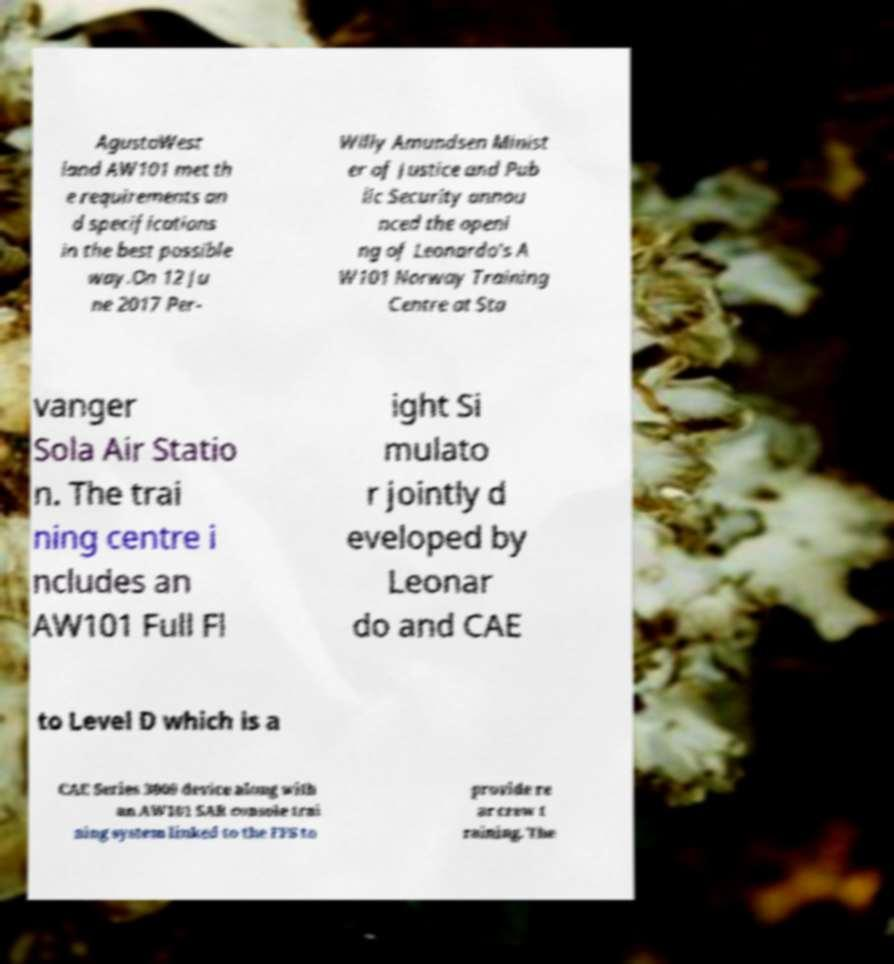Could you assist in decoding the text presented in this image and type it out clearly? AgustaWest land AW101 met th e requirements an d specifications in the best possible way.On 12 Ju ne 2017 Per- Willy Amundsen Minist er of Justice and Pub lic Security annou nced the openi ng of Leonardo's A W101 Norway Training Centre at Sta vanger Sola Air Statio n. The trai ning centre i ncludes an AW101 Full Fl ight Si mulato r jointly d eveloped by Leonar do and CAE to Level D which is a CAE Series 3000 device along with an AW101 SAR console trai ning system linked to the FFS to provide re ar crew t raining. The 